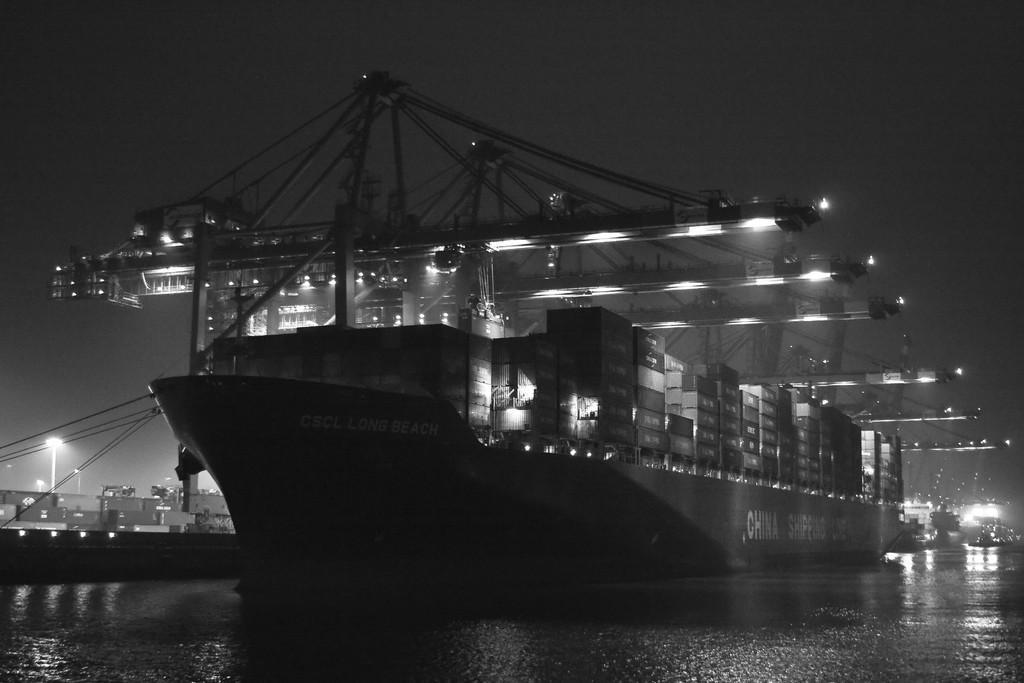How would you summarize this image in a sentence or two? This is a black and white image. We can see a ship sailing on the water. We can see a few houses. We can see some poles and lights. There are a few wires. We can see an object on the right. We can see the sky. 